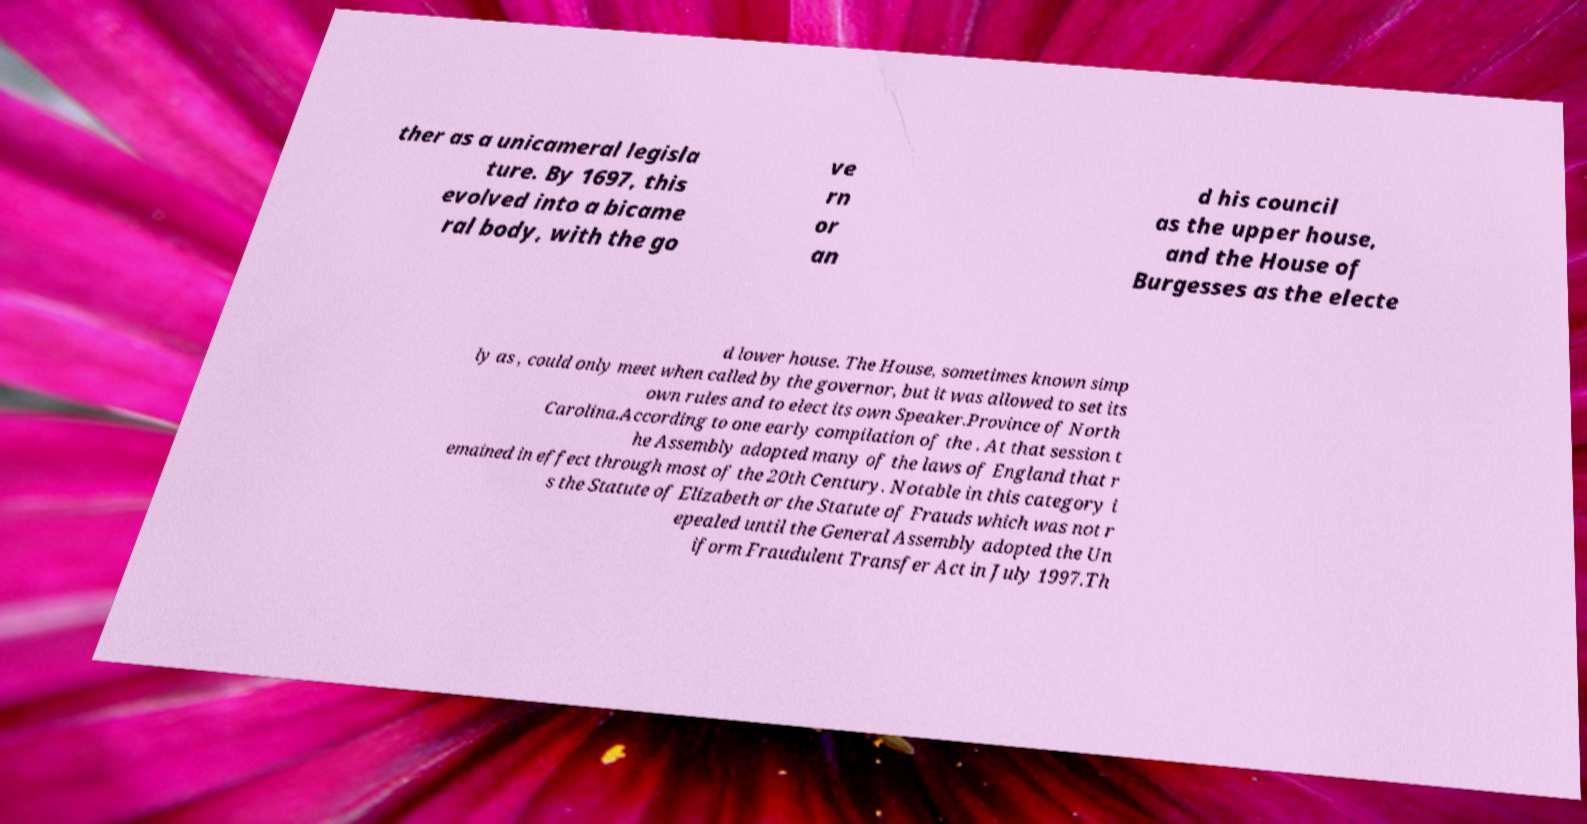Could you assist in decoding the text presented in this image and type it out clearly? ther as a unicameral legisla ture. By 1697, this evolved into a bicame ral body, with the go ve rn or an d his council as the upper house, and the House of Burgesses as the electe d lower house. The House, sometimes known simp ly as , could only meet when called by the governor, but it was allowed to set its own rules and to elect its own Speaker.Province of North Carolina.According to one early compilation of the . At that session t he Assembly adopted many of the laws of England that r emained in effect through most of the 20th Century. Notable in this category i s the Statute of Elizabeth or the Statute of Frauds which was not r epealed until the General Assembly adopted the Un iform Fraudulent Transfer Act in July 1997.Th 